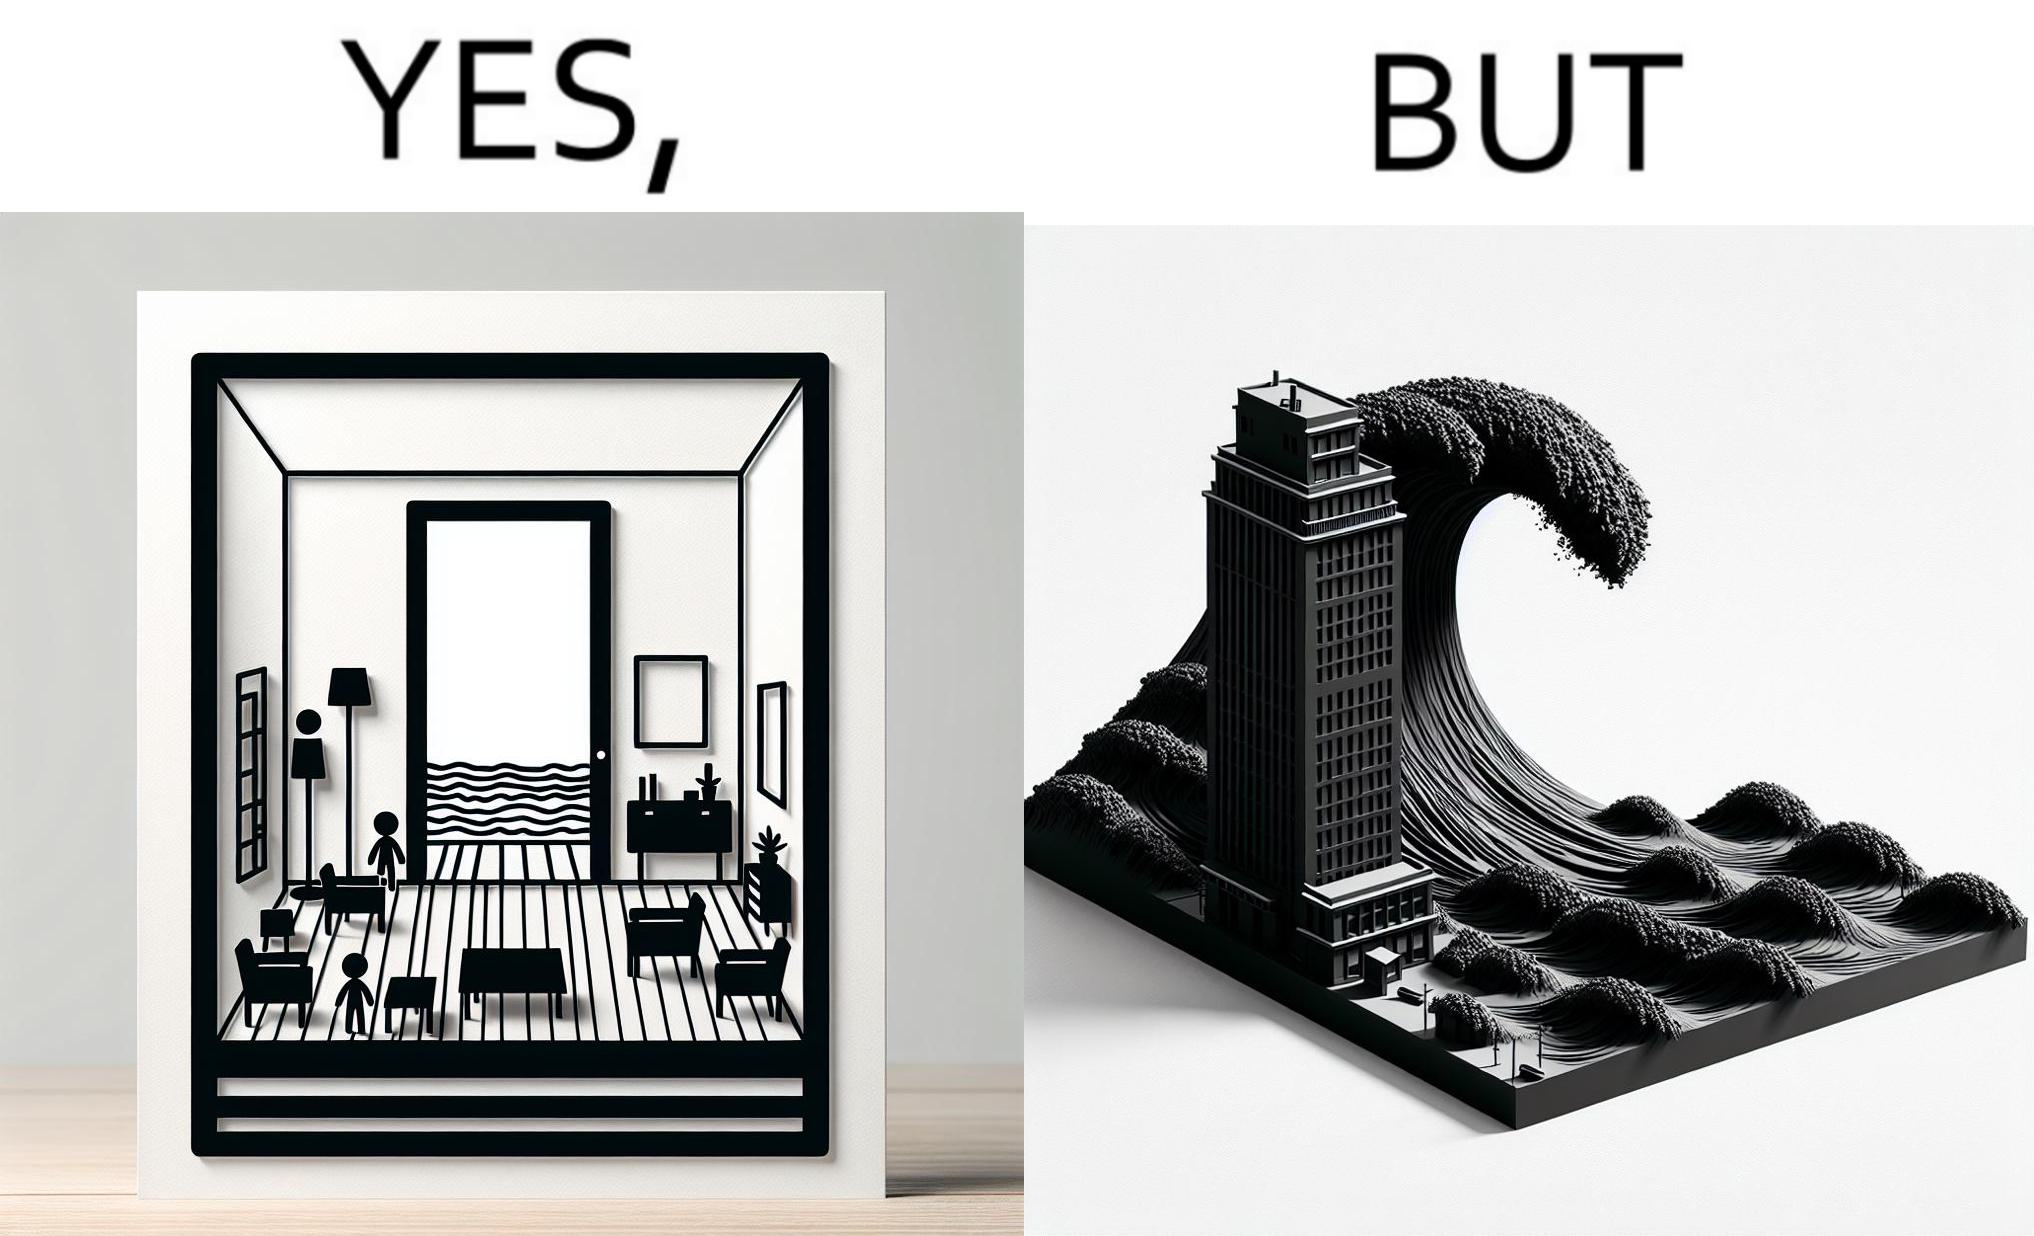Is this image satirical or non-satirical? Yes, this image is satirical. 